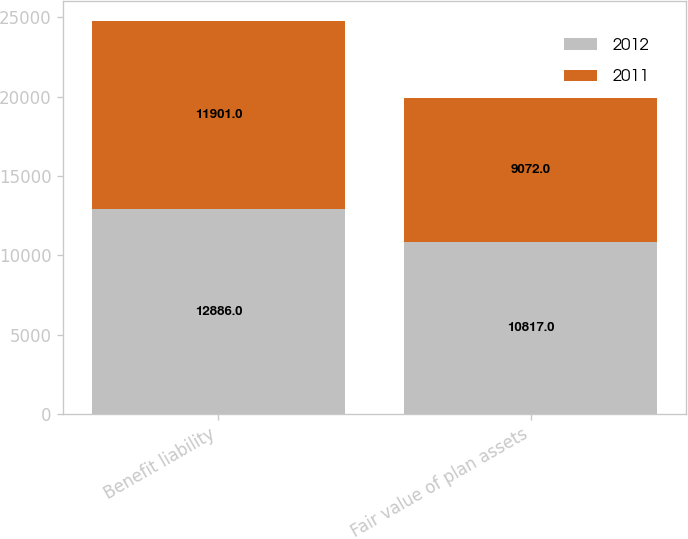<chart> <loc_0><loc_0><loc_500><loc_500><stacked_bar_chart><ecel><fcel>Benefit liability<fcel>Fair value of plan assets<nl><fcel>2012<fcel>12886<fcel>10817<nl><fcel>2011<fcel>11901<fcel>9072<nl></chart> 